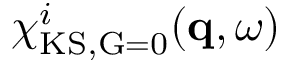Convert formula to latex. <formula><loc_0><loc_0><loc_500><loc_500>\chi _ { K S , \vec { G } = 0 } ^ { i } ( q , \omega )</formula> 